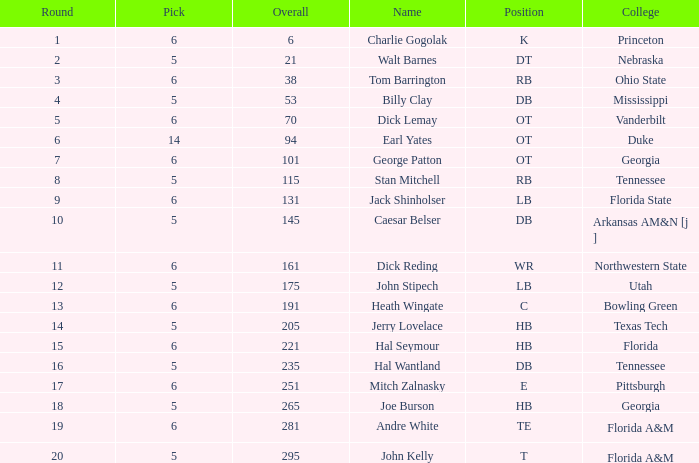What is Pick, when Round is 15? 6.0. 